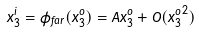<formula> <loc_0><loc_0><loc_500><loc_500>x _ { 3 } ^ { i } = \phi _ { f a r } ( x _ { 3 } ^ { o } ) = A x _ { 3 } ^ { o } + O ( { x _ { 3 } ^ { o } } ^ { 2 } )</formula> 